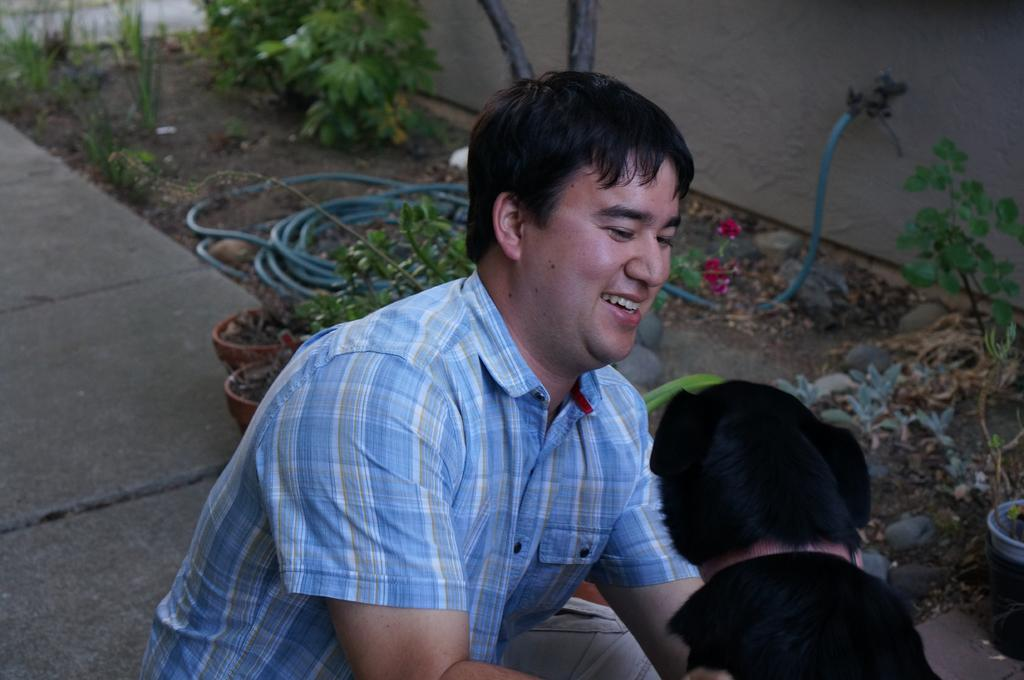Who is present in the image? There is a man in the image. What other living creature can be seen in the image? There is an animal in the image. What type of natural environment is visible in the image? There are trees in the image. What man-made object is present in the image? There is a pipe in the image. How many muscles can be seen on the animal in the image? There is no indication of the animal's muscles in the image, so it cannot be determined. 